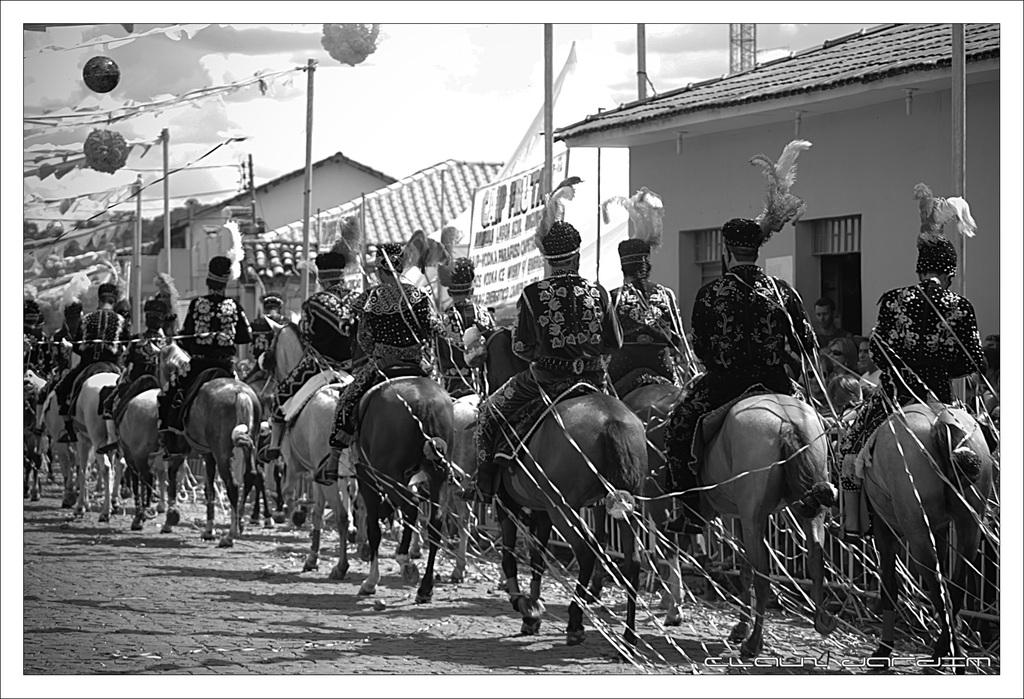What are the people in the image doing? The people in the image are sitting on horses. What can be seen in the background of the image? There is a pole, a house, and the sky visible in the background of the image. What type of pig can be seen participating in the event in the image? There is no pig or event present in the image; it features a group of people sitting on horses. What type of beam is holding up the house in the image? There is no visible beam holding up the house in the image; only the house itself is visible in the background. 